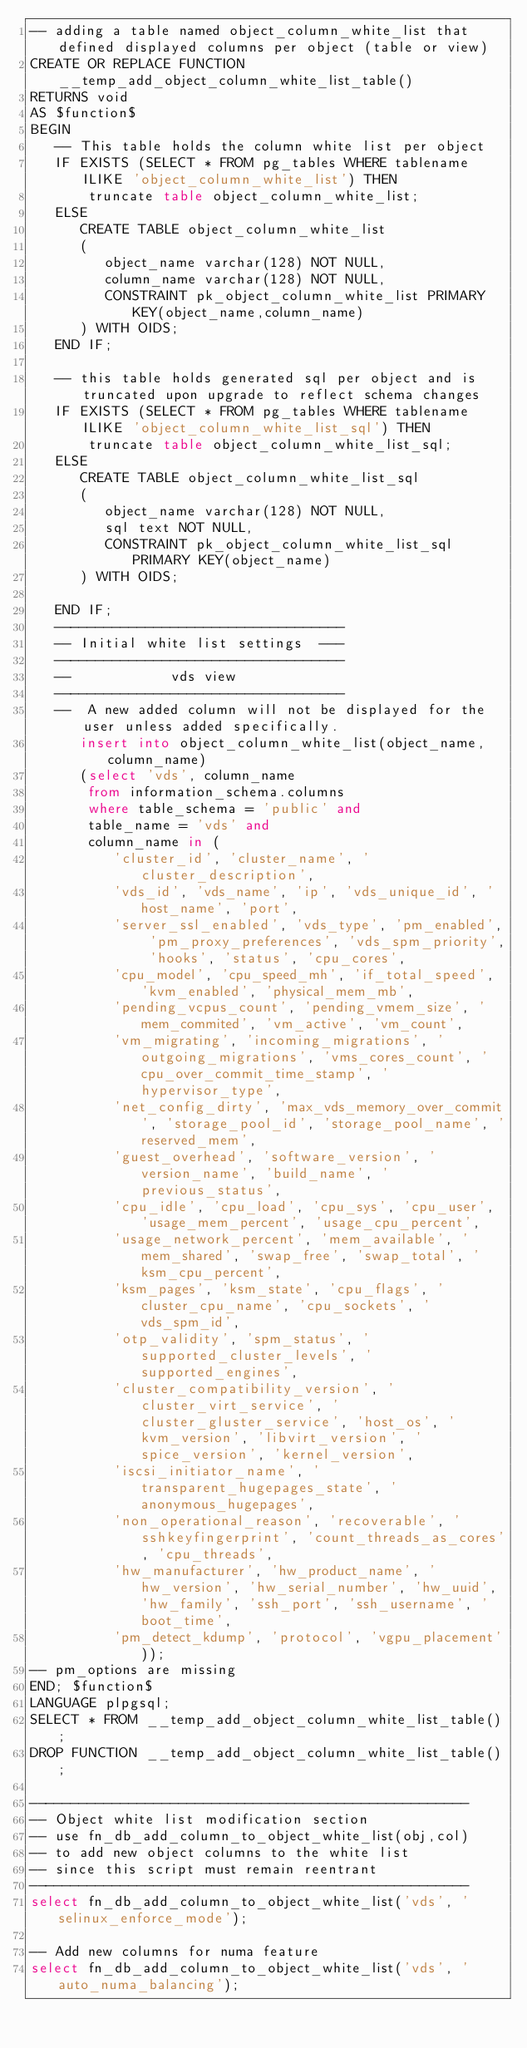<code> <loc_0><loc_0><loc_500><loc_500><_SQL_>-- adding a table named object_column_white_list that defined displayed columns per object (table or view)
CREATE OR REPLACE FUNCTION __temp_add_object_column_white_list_table()
RETURNS void
AS $function$
BEGIN
   -- This table holds the column white list per object
   IF EXISTS (SELECT * FROM pg_tables WHERE tablename ILIKE 'object_column_white_list') THEN
       truncate table object_column_white_list;
   ELSE
      CREATE TABLE object_column_white_list
      (
         object_name varchar(128) NOT NULL,
         column_name varchar(128) NOT NULL,
         CONSTRAINT pk_object_column_white_list PRIMARY KEY(object_name,column_name)
      ) WITH OIDS;
   END IF;

   -- this table holds generated sql per object and is truncated upon upgrade to reflect schema changes
   IF EXISTS (SELECT * FROM pg_tables WHERE tablename ILIKE 'object_column_white_list_sql') THEN
       truncate table object_column_white_list_sql;
   ELSE
      CREATE TABLE object_column_white_list_sql
      (
         object_name varchar(128) NOT NULL,
         sql text NOT NULL,
         CONSTRAINT pk_object_column_white_list_sql PRIMARY KEY(object_name)
      ) WITH OIDS;

   END IF;
   -----------------------------------
   -- Initial white list settings  ---
   -----------------------------------
   --            vds view
   -----------------------------------
   --  A new added column will not be displayed for the user unless added specifically.
      insert into object_column_white_list(object_name,column_name)
      (select 'vds', column_name
       from information_schema.columns
       where table_schema = 'public' and
       table_name = 'vds' and
       column_name in (
          'cluster_id', 'cluster_name', 'cluster_description',
          'vds_id', 'vds_name', 'ip', 'vds_unique_id', 'host_name', 'port',
          'server_ssl_enabled', 'vds_type', 'pm_enabled', 'pm_proxy_preferences', 'vds_spm_priority', 'hooks', 'status', 'cpu_cores',
          'cpu_model', 'cpu_speed_mh', 'if_total_speed', 'kvm_enabled', 'physical_mem_mb',
          'pending_vcpus_count', 'pending_vmem_size', 'mem_commited', 'vm_active', 'vm_count',
          'vm_migrating', 'incoming_migrations', 'outgoing_migrations', 'vms_cores_count', 'cpu_over_commit_time_stamp', 'hypervisor_type',
          'net_config_dirty', 'max_vds_memory_over_commit', 'storage_pool_id', 'storage_pool_name', 'reserved_mem',
          'guest_overhead', 'software_version', 'version_name', 'build_name', 'previous_status',
          'cpu_idle', 'cpu_load', 'cpu_sys', 'cpu_user', 'usage_mem_percent', 'usage_cpu_percent',
          'usage_network_percent', 'mem_available', 'mem_shared', 'swap_free', 'swap_total', 'ksm_cpu_percent',
          'ksm_pages', 'ksm_state', 'cpu_flags', 'cluster_cpu_name', 'cpu_sockets', 'vds_spm_id',
          'otp_validity', 'spm_status', 'supported_cluster_levels', 'supported_engines',
          'cluster_compatibility_version', 'cluster_virt_service', 'cluster_gluster_service', 'host_os', 'kvm_version', 'libvirt_version', 'spice_version', 'kernel_version',
          'iscsi_initiator_name', 'transparent_hugepages_state', 'anonymous_hugepages',
          'non_operational_reason', 'recoverable', 'sshkeyfingerprint', 'count_threads_as_cores', 'cpu_threads',
          'hw_manufacturer', 'hw_product_name', 'hw_version', 'hw_serial_number', 'hw_uuid', 'hw_family', 'ssh_port', 'ssh_username', 'boot_time',
          'pm_detect_kdump', 'protocol', 'vgpu_placement'));
-- pm_options are missing
END; $function$
LANGUAGE plpgsql;
SELECT * FROM __temp_add_object_column_white_list_table();
DROP FUNCTION __temp_add_object_column_white_list_table();

-----------------------------------------------------
-- Object white list modification section
-- use fn_db_add_column_to_object_white_list(obj,col)
-- to add new object columns to the white list
-- since this script must remain reentrant
-----------------------------------------------------
select fn_db_add_column_to_object_white_list('vds', 'selinux_enforce_mode');

-- Add new columns for numa feature
select fn_db_add_column_to_object_white_list('vds', 'auto_numa_balancing');</code> 